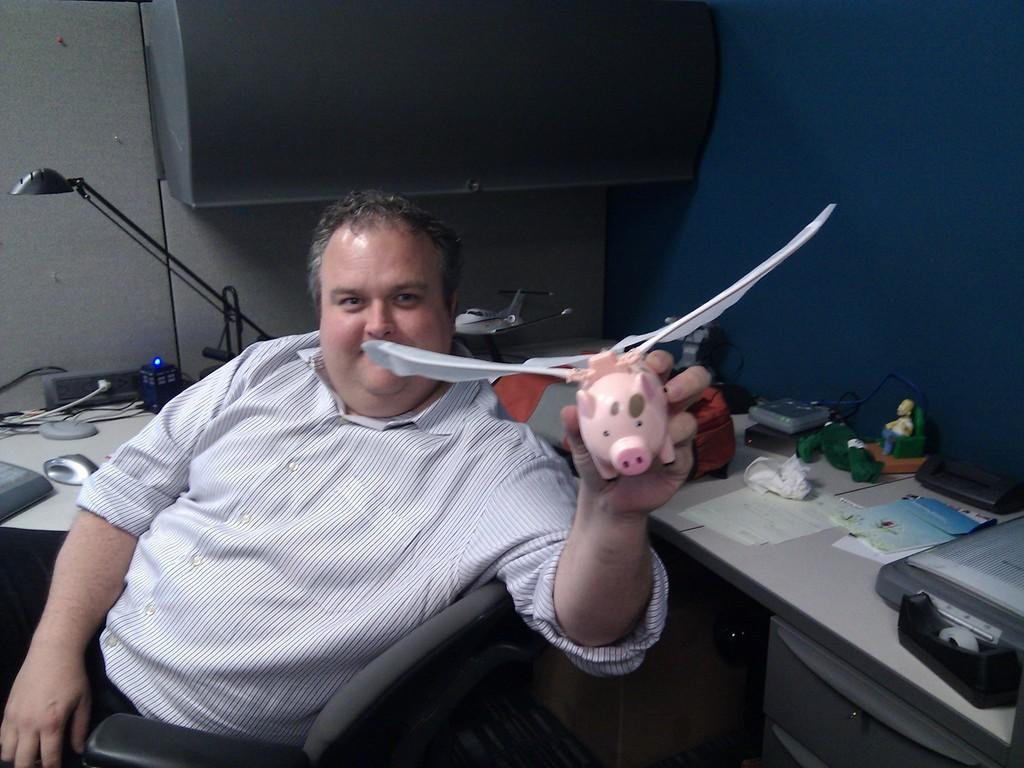What is the main subject of the image? There is a man in the image. What is the man holding in the image? The man is holding a toy. What type of ray can be seen swimming in the image? There is no ray present in the image; it features a man holding a toy. Is there a bed visible in the image? No, there is no bed visible in the image. 